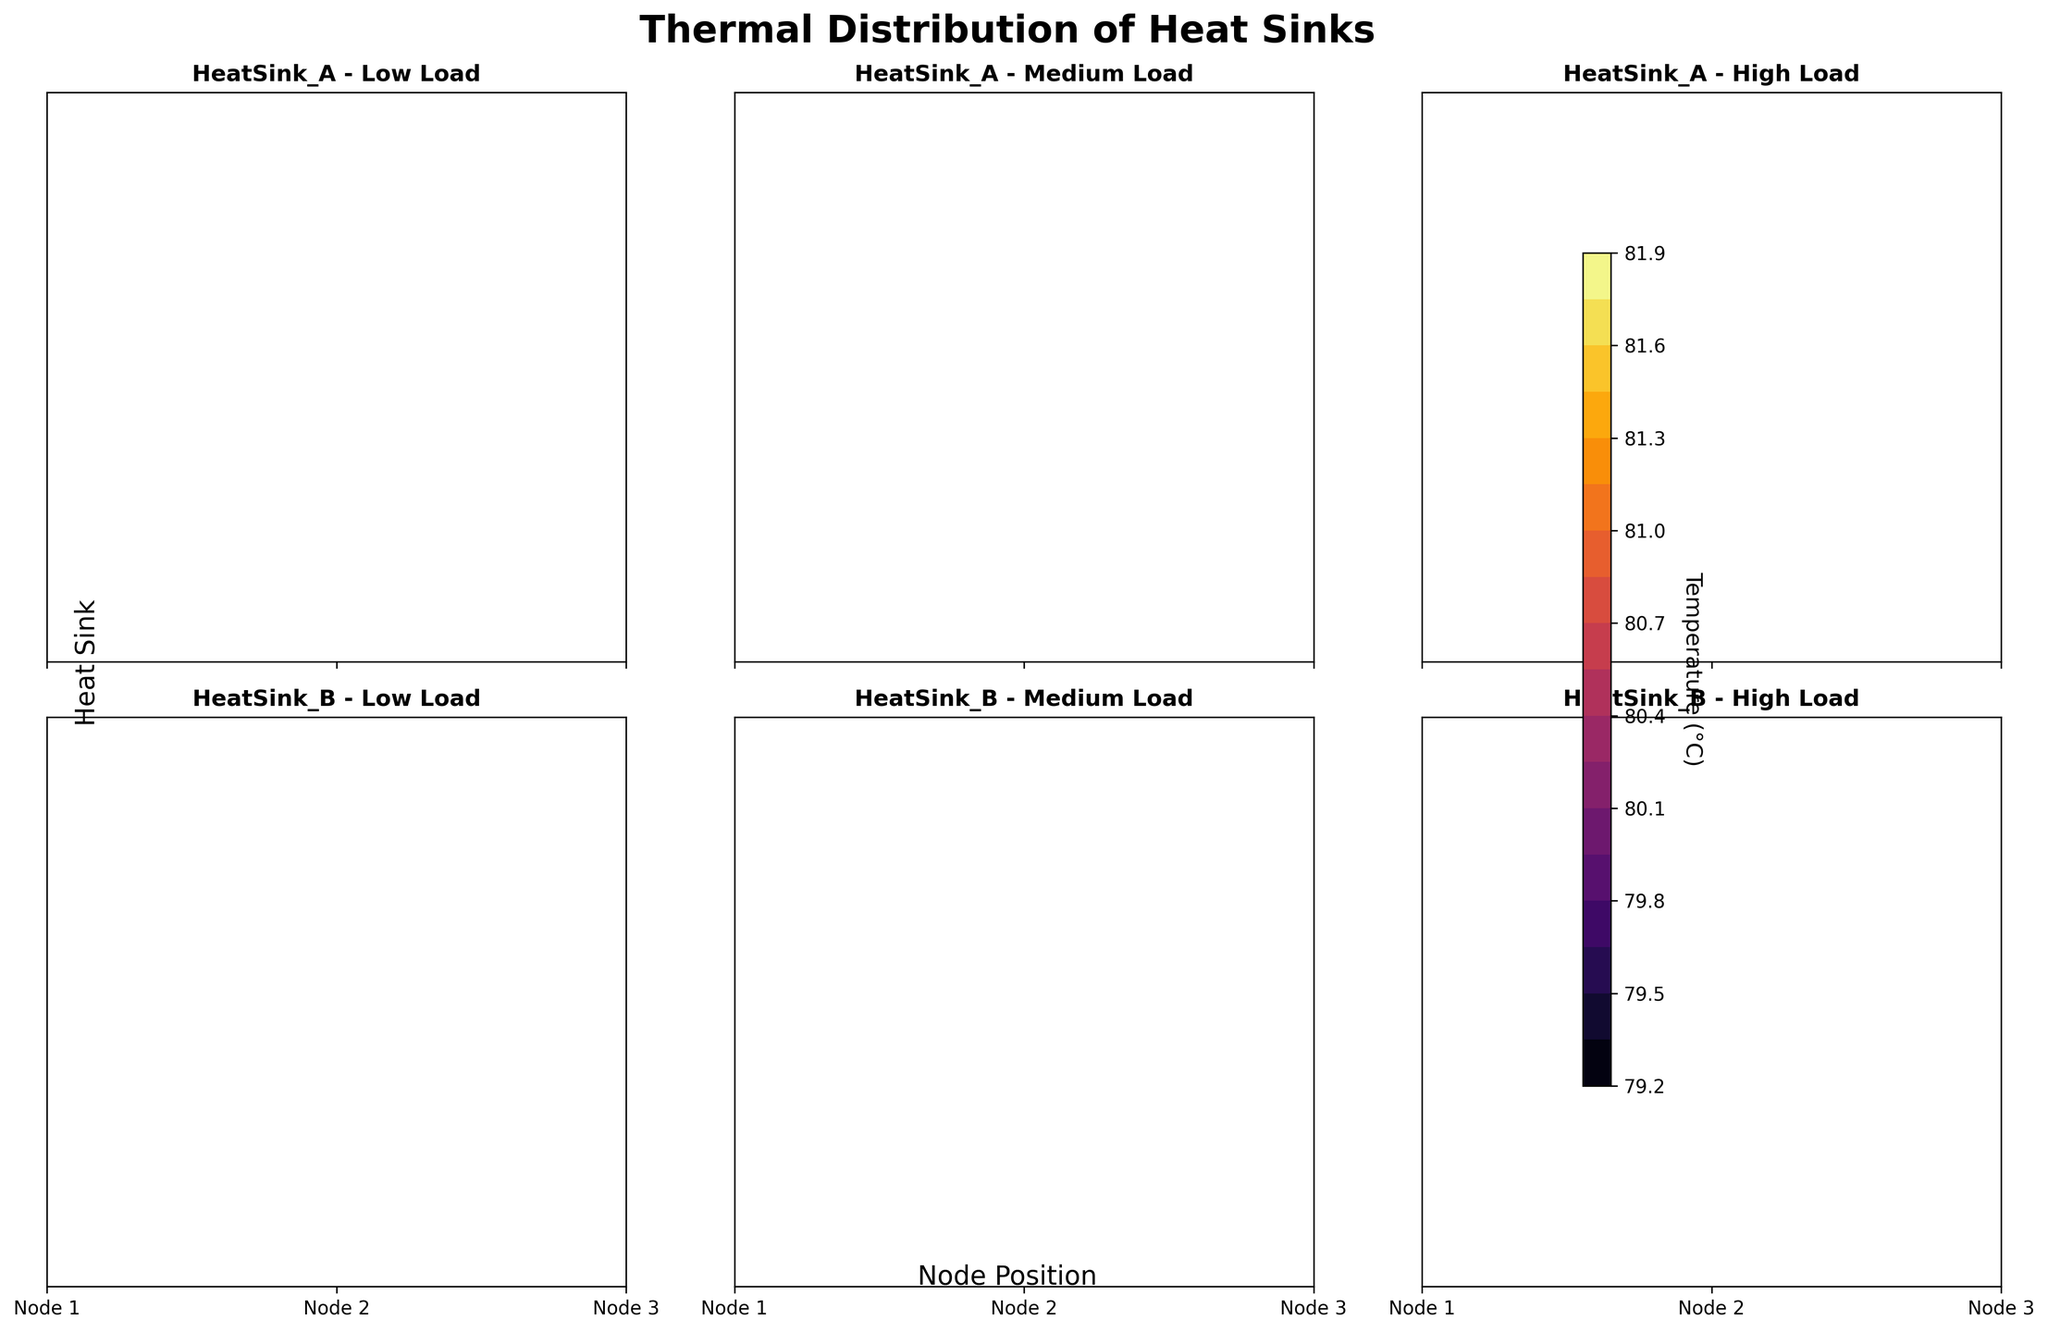How many heat sinks are shown in the figure? There are two heat sinks in the data: HeatSink_A and HeatSink_B. By looking at the titles of the subplots in the figure, we can count two distinct heat sinks.
Answer: 2 What is the title of the figure? The title of the figure is located at the top and reads: 'Thermal Distribution of Heat Sinks'.
Answer: Thermal Distribution of Heat Sinks Which heat sink has a higher maximum temperature under high load condition? Compare the subplots for HeatSink_A and HeatSink_B under high load condition. The contour for HeatSink_B under high load shows a slightly higher temperature than HeatSink_A.
Answer: HeatSink_B What is the temperature range displayed on the figure? The color bar on the side indicates the temperature range. From the figure, the range starts at 44.8°C (darkest color) to 81.9°C (brightest color).
Answer: 44.8°C to 81.9°C Which node has the highest temperature for HeatSink_A under medium load condition? Check the contour plot for HeatSink_A under medium load. Look for the highest temperature which is indicated by the lightest color. Node 2 shows the highest temperature.
Answer: Node 2 What is the average temperature of HeatSink_A under medium load condition? The temperatures for HeatSink_A under medium load condition are 60.3, 61.7, and 59.9. Add these values and divide by 3: (60.3 + 61.7 + 59.9) / 3 = 60.63
Answer: 60.63°C How does the temperature distribution change from low to high load condition for HeatSink_A? Observe the three subplots for HeatSink_A. The temperature increases from low to high load conditions, with the contour colors moving from darker to lighter. This indicates higher temperatures at higher loads.
Answer: Increases What load condition causes the most uniform temperature distribution for HeatSink_B? Check the subplot for each load condition of HeatSink_B. Uniform distribution means less variation in contour colors. Under medium load, the contour colors are the most uniform, indicating minimal temperature differences.
Answer: Medium load How does the temperature difference between Node 1 and Node 3 for HeatSink_A under high load compare to the same nodes for HeatSink_B under the same load? For HeatSink_A under high load, temperatures are 78.1 (Node 1) and 77.6 (Node 3), so the difference is 0.5°C. For HeatSink_B, temperatures are 80.4 (Node 1) and 79.2 (Node 3), making a difference of 1.2°C.
Answer: 0.5°C for HeatSink_A and 1.2°C for HeatSink_B Which load condition has the highest overall temperature for HeatSink_B? Compare the subplots for different load conditions in HeatSink_B. The high load condition shows the lightest colors indicating the highest temperatures.
Answer: High load 